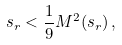<formula> <loc_0><loc_0><loc_500><loc_500>s _ { r } < \frac { 1 } { 9 } M ^ { 2 } ( s _ { r } ) \, ,</formula> 